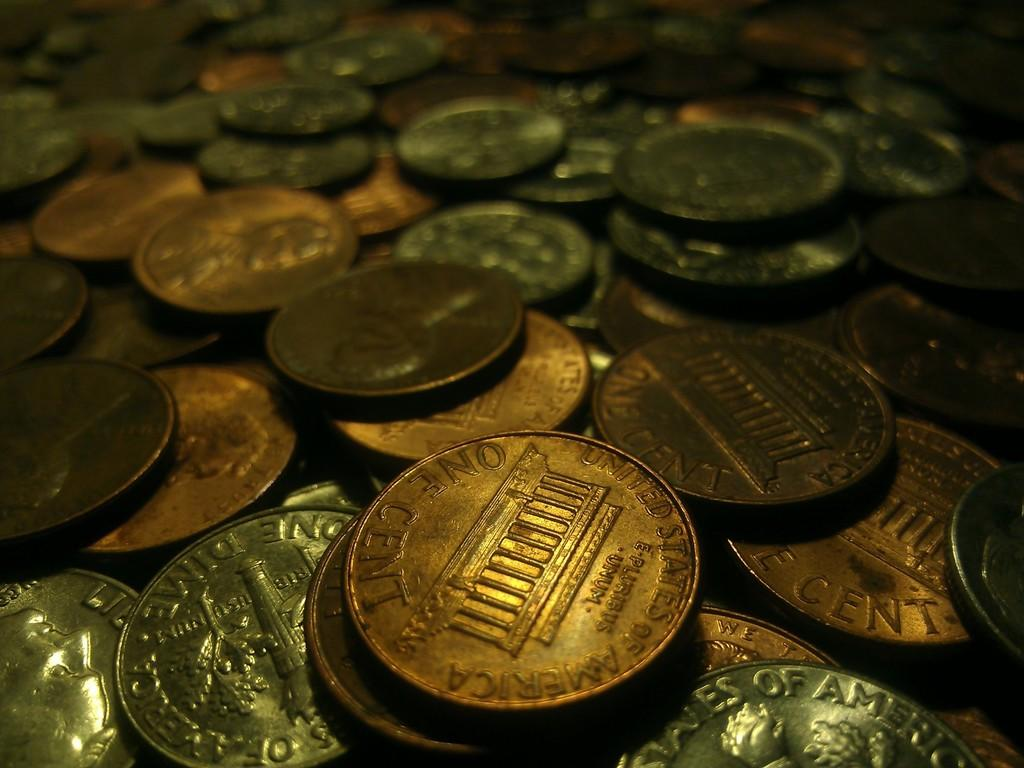<image>
Relay a brief, clear account of the picture shown. A large numbe of coins the nearest one being a one cent US coin. 